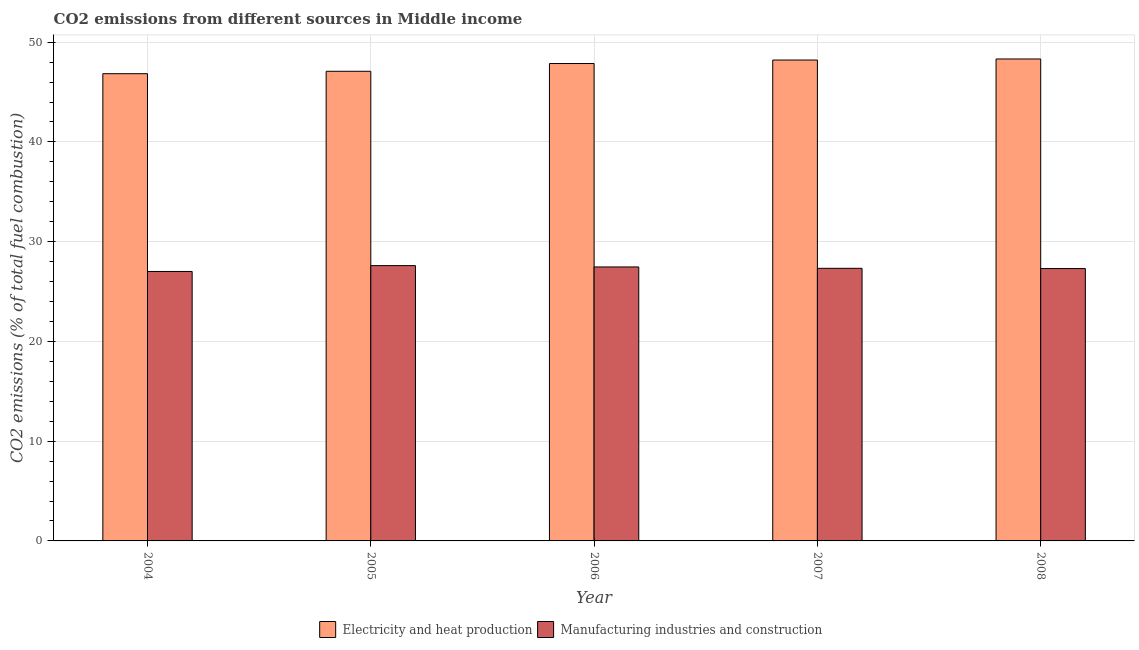How many different coloured bars are there?
Offer a very short reply. 2. Are the number of bars per tick equal to the number of legend labels?
Your answer should be very brief. Yes. How many bars are there on the 4th tick from the right?
Your answer should be very brief. 2. What is the label of the 1st group of bars from the left?
Provide a short and direct response. 2004. What is the co2 emissions due to manufacturing industries in 2006?
Your answer should be very brief. 27.47. Across all years, what is the maximum co2 emissions due to manufacturing industries?
Your response must be concise. 27.6. Across all years, what is the minimum co2 emissions due to electricity and heat production?
Keep it short and to the point. 46.84. What is the total co2 emissions due to electricity and heat production in the graph?
Your answer should be compact. 238.3. What is the difference between the co2 emissions due to electricity and heat production in 2005 and that in 2008?
Offer a very short reply. -1.24. What is the difference between the co2 emissions due to electricity and heat production in 2006 and the co2 emissions due to manufacturing industries in 2004?
Offer a very short reply. 1.02. What is the average co2 emissions due to electricity and heat production per year?
Provide a succinct answer. 47.66. In the year 2006, what is the difference between the co2 emissions due to electricity and heat production and co2 emissions due to manufacturing industries?
Your answer should be very brief. 0. In how many years, is the co2 emissions due to electricity and heat production greater than 40 %?
Provide a short and direct response. 5. What is the ratio of the co2 emissions due to electricity and heat production in 2004 to that in 2008?
Your answer should be very brief. 0.97. Is the difference between the co2 emissions due to manufacturing industries in 2005 and 2007 greater than the difference between the co2 emissions due to electricity and heat production in 2005 and 2007?
Your response must be concise. No. What is the difference between the highest and the second highest co2 emissions due to electricity and heat production?
Give a very brief answer. 0.11. What is the difference between the highest and the lowest co2 emissions due to manufacturing industries?
Keep it short and to the point. 0.59. In how many years, is the co2 emissions due to electricity and heat production greater than the average co2 emissions due to electricity and heat production taken over all years?
Your answer should be compact. 3. Is the sum of the co2 emissions due to manufacturing industries in 2006 and 2007 greater than the maximum co2 emissions due to electricity and heat production across all years?
Offer a very short reply. Yes. What does the 2nd bar from the left in 2004 represents?
Make the answer very short. Manufacturing industries and construction. What does the 1st bar from the right in 2004 represents?
Your answer should be compact. Manufacturing industries and construction. How many bars are there?
Provide a short and direct response. 10. How many years are there in the graph?
Offer a very short reply. 5. Does the graph contain grids?
Your response must be concise. Yes. How many legend labels are there?
Provide a short and direct response. 2. What is the title of the graph?
Keep it short and to the point. CO2 emissions from different sources in Middle income. Does "% of gross capital formation" appear as one of the legend labels in the graph?
Provide a short and direct response. No. What is the label or title of the X-axis?
Give a very brief answer. Year. What is the label or title of the Y-axis?
Offer a terse response. CO2 emissions (% of total fuel combustion). What is the CO2 emissions (% of total fuel combustion) of Electricity and heat production in 2004?
Ensure brevity in your answer.  46.84. What is the CO2 emissions (% of total fuel combustion) of Manufacturing industries and construction in 2004?
Provide a succinct answer. 27.01. What is the CO2 emissions (% of total fuel combustion) of Electricity and heat production in 2005?
Provide a short and direct response. 47.08. What is the CO2 emissions (% of total fuel combustion) in Manufacturing industries and construction in 2005?
Your answer should be very brief. 27.6. What is the CO2 emissions (% of total fuel combustion) in Electricity and heat production in 2006?
Ensure brevity in your answer.  47.86. What is the CO2 emissions (% of total fuel combustion) of Manufacturing industries and construction in 2006?
Offer a very short reply. 27.47. What is the CO2 emissions (% of total fuel combustion) in Electricity and heat production in 2007?
Your answer should be compact. 48.21. What is the CO2 emissions (% of total fuel combustion) in Manufacturing industries and construction in 2007?
Keep it short and to the point. 27.33. What is the CO2 emissions (% of total fuel combustion) of Electricity and heat production in 2008?
Your answer should be compact. 48.32. What is the CO2 emissions (% of total fuel combustion) of Manufacturing industries and construction in 2008?
Your answer should be very brief. 27.31. Across all years, what is the maximum CO2 emissions (% of total fuel combustion) in Electricity and heat production?
Your answer should be compact. 48.32. Across all years, what is the maximum CO2 emissions (% of total fuel combustion) of Manufacturing industries and construction?
Keep it short and to the point. 27.6. Across all years, what is the minimum CO2 emissions (% of total fuel combustion) in Electricity and heat production?
Keep it short and to the point. 46.84. Across all years, what is the minimum CO2 emissions (% of total fuel combustion) of Manufacturing industries and construction?
Give a very brief answer. 27.01. What is the total CO2 emissions (% of total fuel combustion) of Electricity and heat production in the graph?
Provide a short and direct response. 238.3. What is the total CO2 emissions (% of total fuel combustion) of Manufacturing industries and construction in the graph?
Keep it short and to the point. 136.71. What is the difference between the CO2 emissions (% of total fuel combustion) in Electricity and heat production in 2004 and that in 2005?
Offer a very short reply. -0.24. What is the difference between the CO2 emissions (% of total fuel combustion) of Manufacturing industries and construction in 2004 and that in 2005?
Give a very brief answer. -0.59. What is the difference between the CO2 emissions (% of total fuel combustion) of Electricity and heat production in 2004 and that in 2006?
Your answer should be very brief. -1.02. What is the difference between the CO2 emissions (% of total fuel combustion) in Manufacturing industries and construction in 2004 and that in 2006?
Your response must be concise. -0.45. What is the difference between the CO2 emissions (% of total fuel combustion) in Electricity and heat production in 2004 and that in 2007?
Give a very brief answer. -1.37. What is the difference between the CO2 emissions (% of total fuel combustion) of Manufacturing industries and construction in 2004 and that in 2007?
Give a very brief answer. -0.32. What is the difference between the CO2 emissions (% of total fuel combustion) in Electricity and heat production in 2004 and that in 2008?
Provide a succinct answer. -1.48. What is the difference between the CO2 emissions (% of total fuel combustion) in Manufacturing industries and construction in 2004 and that in 2008?
Keep it short and to the point. -0.29. What is the difference between the CO2 emissions (% of total fuel combustion) in Electricity and heat production in 2005 and that in 2006?
Offer a terse response. -0.78. What is the difference between the CO2 emissions (% of total fuel combustion) in Manufacturing industries and construction in 2005 and that in 2006?
Provide a succinct answer. 0.13. What is the difference between the CO2 emissions (% of total fuel combustion) of Electricity and heat production in 2005 and that in 2007?
Make the answer very short. -1.13. What is the difference between the CO2 emissions (% of total fuel combustion) in Manufacturing industries and construction in 2005 and that in 2007?
Ensure brevity in your answer.  0.27. What is the difference between the CO2 emissions (% of total fuel combustion) in Electricity and heat production in 2005 and that in 2008?
Give a very brief answer. -1.24. What is the difference between the CO2 emissions (% of total fuel combustion) of Manufacturing industries and construction in 2005 and that in 2008?
Offer a terse response. 0.29. What is the difference between the CO2 emissions (% of total fuel combustion) of Electricity and heat production in 2006 and that in 2007?
Offer a very short reply. -0.35. What is the difference between the CO2 emissions (% of total fuel combustion) of Manufacturing industries and construction in 2006 and that in 2007?
Provide a short and direct response. 0.14. What is the difference between the CO2 emissions (% of total fuel combustion) of Electricity and heat production in 2006 and that in 2008?
Keep it short and to the point. -0.46. What is the difference between the CO2 emissions (% of total fuel combustion) in Manufacturing industries and construction in 2006 and that in 2008?
Your answer should be very brief. 0.16. What is the difference between the CO2 emissions (% of total fuel combustion) of Electricity and heat production in 2007 and that in 2008?
Make the answer very short. -0.11. What is the difference between the CO2 emissions (% of total fuel combustion) of Manufacturing industries and construction in 2007 and that in 2008?
Your response must be concise. 0.02. What is the difference between the CO2 emissions (% of total fuel combustion) in Electricity and heat production in 2004 and the CO2 emissions (% of total fuel combustion) in Manufacturing industries and construction in 2005?
Provide a succinct answer. 19.24. What is the difference between the CO2 emissions (% of total fuel combustion) of Electricity and heat production in 2004 and the CO2 emissions (% of total fuel combustion) of Manufacturing industries and construction in 2006?
Ensure brevity in your answer.  19.37. What is the difference between the CO2 emissions (% of total fuel combustion) in Electricity and heat production in 2004 and the CO2 emissions (% of total fuel combustion) in Manufacturing industries and construction in 2007?
Offer a terse response. 19.51. What is the difference between the CO2 emissions (% of total fuel combustion) in Electricity and heat production in 2004 and the CO2 emissions (% of total fuel combustion) in Manufacturing industries and construction in 2008?
Your answer should be compact. 19.53. What is the difference between the CO2 emissions (% of total fuel combustion) in Electricity and heat production in 2005 and the CO2 emissions (% of total fuel combustion) in Manufacturing industries and construction in 2006?
Offer a terse response. 19.61. What is the difference between the CO2 emissions (% of total fuel combustion) in Electricity and heat production in 2005 and the CO2 emissions (% of total fuel combustion) in Manufacturing industries and construction in 2007?
Ensure brevity in your answer.  19.75. What is the difference between the CO2 emissions (% of total fuel combustion) in Electricity and heat production in 2005 and the CO2 emissions (% of total fuel combustion) in Manufacturing industries and construction in 2008?
Keep it short and to the point. 19.77. What is the difference between the CO2 emissions (% of total fuel combustion) of Electricity and heat production in 2006 and the CO2 emissions (% of total fuel combustion) of Manufacturing industries and construction in 2007?
Offer a very short reply. 20.53. What is the difference between the CO2 emissions (% of total fuel combustion) of Electricity and heat production in 2006 and the CO2 emissions (% of total fuel combustion) of Manufacturing industries and construction in 2008?
Offer a terse response. 20.55. What is the difference between the CO2 emissions (% of total fuel combustion) of Electricity and heat production in 2007 and the CO2 emissions (% of total fuel combustion) of Manufacturing industries and construction in 2008?
Offer a very short reply. 20.9. What is the average CO2 emissions (% of total fuel combustion) in Electricity and heat production per year?
Ensure brevity in your answer.  47.66. What is the average CO2 emissions (% of total fuel combustion) of Manufacturing industries and construction per year?
Provide a short and direct response. 27.34. In the year 2004, what is the difference between the CO2 emissions (% of total fuel combustion) of Electricity and heat production and CO2 emissions (% of total fuel combustion) of Manufacturing industries and construction?
Offer a terse response. 19.83. In the year 2005, what is the difference between the CO2 emissions (% of total fuel combustion) in Electricity and heat production and CO2 emissions (% of total fuel combustion) in Manufacturing industries and construction?
Ensure brevity in your answer.  19.48. In the year 2006, what is the difference between the CO2 emissions (% of total fuel combustion) of Electricity and heat production and CO2 emissions (% of total fuel combustion) of Manufacturing industries and construction?
Make the answer very short. 20.39. In the year 2007, what is the difference between the CO2 emissions (% of total fuel combustion) of Electricity and heat production and CO2 emissions (% of total fuel combustion) of Manufacturing industries and construction?
Your response must be concise. 20.88. In the year 2008, what is the difference between the CO2 emissions (% of total fuel combustion) of Electricity and heat production and CO2 emissions (% of total fuel combustion) of Manufacturing industries and construction?
Offer a terse response. 21.01. What is the ratio of the CO2 emissions (% of total fuel combustion) in Electricity and heat production in 2004 to that in 2005?
Your response must be concise. 0.99. What is the ratio of the CO2 emissions (% of total fuel combustion) in Manufacturing industries and construction in 2004 to that in 2005?
Give a very brief answer. 0.98. What is the ratio of the CO2 emissions (% of total fuel combustion) of Electricity and heat production in 2004 to that in 2006?
Give a very brief answer. 0.98. What is the ratio of the CO2 emissions (% of total fuel combustion) of Manufacturing industries and construction in 2004 to that in 2006?
Give a very brief answer. 0.98. What is the ratio of the CO2 emissions (% of total fuel combustion) in Electricity and heat production in 2004 to that in 2007?
Your response must be concise. 0.97. What is the ratio of the CO2 emissions (% of total fuel combustion) of Electricity and heat production in 2004 to that in 2008?
Give a very brief answer. 0.97. What is the ratio of the CO2 emissions (% of total fuel combustion) of Manufacturing industries and construction in 2004 to that in 2008?
Provide a succinct answer. 0.99. What is the ratio of the CO2 emissions (% of total fuel combustion) of Electricity and heat production in 2005 to that in 2006?
Your response must be concise. 0.98. What is the ratio of the CO2 emissions (% of total fuel combustion) in Manufacturing industries and construction in 2005 to that in 2006?
Your response must be concise. 1. What is the ratio of the CO2 emissions (% of total fuel combustion) in Electricity and heat production in 2005 to that in 2007?
Offer a terse response. 0.98. What is the ratio of the CO2 emissions (% of total fuel combustion) of Manufacturing industries and construction in 2005 to that in 2007?
Offer a very short reply. 1.01. What is the ratio of the CO2 emissions (% of total fuel combustion) of Electricity and heat production in 2005 to that in 2008?
Provide a short and direct response. 0.97. What is the ratio of the CO2 emissions (% of total fuel combustion) of Manufacturing industries and construction in 2005 to that in 2008?
Provide a short and direct response. 1.01. What is the ratio of the CO2 emissions (% of total fuel combustion) of Electricity and heat production in 2006 to that in 2007?
Provide a short and direct response. 0.99. What is the ratio of the CO2 emissions (% of total fuel combustion) in Electricity and heat production in 2006 to that in 2008?
Give a very brief answer. 0.99. What is the ratio of the CO2 emissions (% of total fuel combustion) of Manufacturing industries and construction in 2006 to that in 2008?
Offer a terse response. 1.01. What is the difference between the highest and the second highest CO2 emissions (% of total fuel combustion) in Electricity and heat production?
Your answer should be very brief. 0.11. What is the difference between the highest and the second highest CO2 emissions (% of total fuel combustion) of Manufacturing industries and construction?
Keep it short and to the point. 0.13. What is the difference between the highest and the lowest CO2 emissions (% of total fuel combustion) in Electricity and heat production?
Provide a succinct answer. 1.48. What is the difference between the highest and the lowest CO2 emissions (% of total fuel combustion) in Manufacturing industries and construction?
Give a very brief answer. 0.59. 